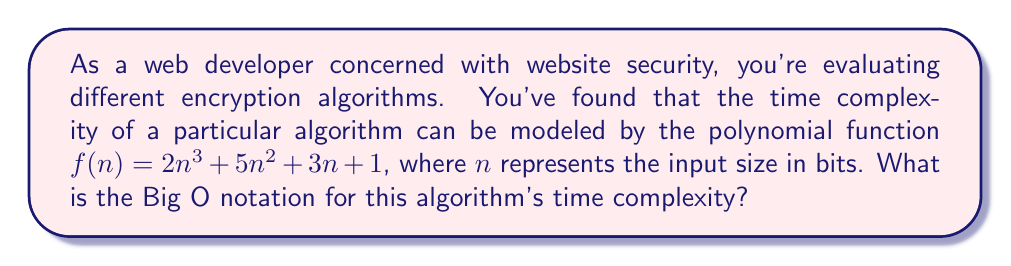Can you answer this question? To determine the Big O notation for the given polynomial function, we need to follow these steps:

1. Identify the highest degree term in the polynomial:
   $f(n) = 2n^3 + 5n^2 + 3n + 1$
   The highest degree term is $2n^3$.

2. Remove the constant coefficient:
   $2n^3$ becomes $n^3$

3. Express the result in Big O notation:
   The time complexity is $O(n^3)$

Explanation of why lower-order terms are ignored:
- As $n$ grows larger, the impact of lower-order terms ($5n^2$, $3n$, and $1$) becomes negligible compared to $n^3$.
- Big O notation represents the upper bound of the growth rate, so we focus on the term that grows the fastest as $n$ increases.

For web security purposes, understanding this time complexity helps you assess the scalability and performance of the encryption algorithm for different input sizes, which is crucial when dealing with varying amounts of data in web applications.
Answer: $O(n^3)$ 